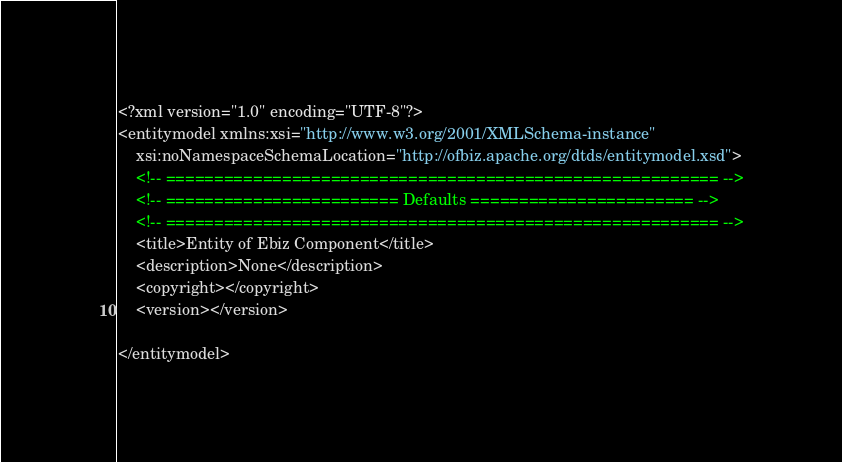Convert code to text. <code><loc_0><loc_0><loc_500><loc_500><_XML_><?xml version="1.0" encoding="UTF-8"?>
<entitymodel xmlns:xsi="http://www.w3.org/2001/XMLSchema-instance"
    xsi:noNamespaceSchemaLocation="http://ofbiz.apache.org/dtds/entitymodel.xsd">
    <!-- ========================================================= -->
    <!-- ======================== Defaults ======================= -->
    <!-- ========================================================= -->
    <title>Entity of Ebiz Component</title>
    <description>None</description>
    <copyright></copyright>
    <version></version>

</entitymodel></code> 